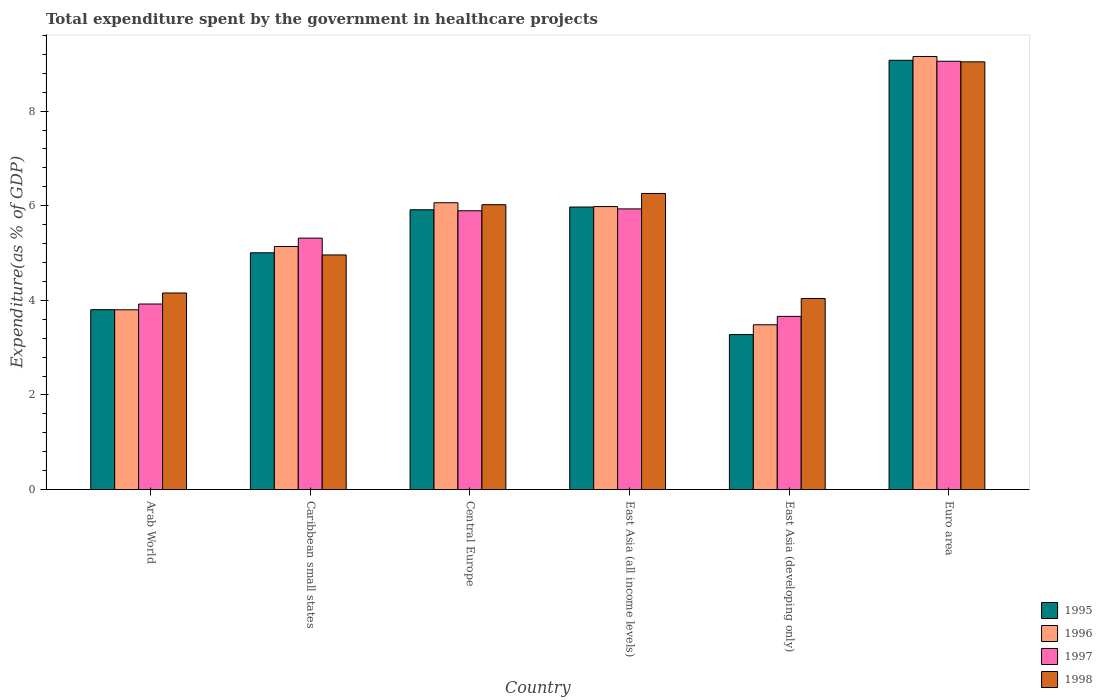Are the number of bars per tick equal to the number of legend labels?
Give a very brief answer. Yes. What is the label of the 1st group of bars from the left?
Offer a very short reply. Arab World. What is the total expenditure spent by the government in healthcare projects in 1995 in East Asia (developing only)?
Ensure brevity in your answer.  3.28. Across all countries, what is the maximum total expenditure spent by the government in healthcare projects in 1996?
Keep it short and to the point. 9.16. Across all countries, what is the minimum total expenditure spent by the government in healthcare projects in 1997?
Your answer should be very brief. 3.66. In which country was the total expenditure spent by the government in healthcare projects in 1996 maximum?
Make the answer very short. Euro area. In which country was the total expenditure spent by the government in healthcare projects in 1997 minimum?
Ensure brevity in your answer.  East Asia (developing only). What is the total total expenditure spent by the government in healthcare projects in 1997 in the graph?
Provide a short and direct response. 33.78. What is the difference between the total expenditure spent by the government in healthcare projects in 1995 in Central Europe and that in East Asia (all income levels)?
Offer a very short reply. -0.06. What is the difference between the total expenditure spent by the government in healthcare projects in 1995 in Euro area and the total expenditure spent by the government in healthcare projects in 1998 in Caribbean small states?
Keep it short and to the point. 4.12. What is the average total expenditure spent by the government in healthcare projects in 1995 per country?
Provide a succinct answer. 5.51. What is the difference between the total expenditure spent by the government in healthcare projects of/in 1995 and total expenditure spent by the government in healthcare projects of/in 1998 in Caribbean small states?
Offer a terse response. 0.05. What is the ratio of the total expenditure spent by the government in healthcare projects in 1997 in Central Europe to that in East Asia (all income levels)?
Offer a very short reply. 0.99. Is the total expenditure spent by the government in healthcare projects in 1998 in Central Europe less than that in East Asia (all income levels)?
Offer a terse response. Yes. What is the difference between the highest and the second highest total expenditure spent by the government in healthcare projects in 1997?
Make the answer very short. 3.16. What is the difference between the highest and the lowest total expenditure spent by the government in healthcare projects in 1998?
Your response must be concise. 5. In how many countries, is the total expenditure spent by the government in healthcare projects in 1997 greater than the average total expenditure spent by the government in healthcare projects in 1997 taken over all countries?
Provide a short and direct response. 3. What does the 3rd bar from the left in Caribbean small states represents?
Your answer should be compact. 1997. What does the 1st bar from the right in East Asia (all income levels) represents?
Offer a terse response. 1998. How many bars are there?
Provide a succinct answer. 24. Are all the bars in the graph horizontal?
Your response must be concise. No. How many countries are there in the graph?
Your response must be concise. 6. Are the values on the major ticks of Y-axis written in scientific E-notation?
Give a very brief answer. No. Does the graph contain any zero values?
Provide a succinct answer. No. Does the graph contain grids?
Your answer should be very brief. No. Where does the legend appear in the graph?
Ensure brevity in your answer.  Bottom right. How many legend labels are there?
Make the answer very short. 4. What is the title of the graph?
Keep it short and to the point. Total expenditure spent by the government in healthcare projects. What is the label or title of the Y-axis?
Make the answer very short. Expenditure(as % of GDP). What is the Expenditure(as % of GDP) in 1995 in Arab World?
Your response must be concise. 3.8. What is the Expenditure(as % of GDP) in 1996 in Arab World?
Your answer should be compact. 3.8. What is the Expenditure(as % of GDP) in 1997 in Arab World?
Make the answer very short. 3.92. What is the Expenditure(as % of GDP) of 1998 in Arab World?
Offer a very short reply. 4.16. What is the Expenditure(as % of GDP) in 1995 in Caribbean small states?
Give a very brief answer. 5.01. What is the Expenditure(as % of GDP) of 1996 in Caribbean small states?
Ensure brevity in your answer.  5.14. What is the Expenditure(as % of GDP) in 1997 in Caribbean small states?
Your response must be concise. 5.32. What is the Expenditure(as % of GDP) of 1998 in Caribbean small states?
Give a very brief answer. 4.96. What is the Expenditure(as % of GDP) in 1995 in Central Europe?
Provide a short and direct response. 5.92. What is the Expenditure(as % of GDP) of 1996 in Central Europe?
Offer a very short reply. 6.06. What is the Expenditure(as % of GDP) of 1997 in Central Europe?
Ensure brevity in your answer.  5.89. What is the Expenditure(as % of GDP) of 1998 in Central Europe?
Your response must be concise. 6.02. What is the Expenditure(as % of GDP) of 1995 in East Asia (all income levels)?
Provide a short and direct response. 5.97. What is the Expenditure(as % of GDP) of 1996 in East Asia (all income levels)?
Ensure brevity in your answer.  5.98. What is the Expenditure(as % of GDP) of 1997 in East Asia (all income levels)?
Your answer should be compact. 5.93. What is the Expenditure(as % of GDP) of 1998 in East Asia (all income levels)?
Provide a succinct answer. 6.26. What is the Expenditure(as % of GDP) of 1995 in East Asia (developing only)?
Offer a terse response. 3.28. What is the Expenditure(as % of GDP) in 1996 in East Asia (developing only)?
Ensure brevity in your answer.  3.48. What is the Expenditure(as % of GDP) in 1997 in East Asia (developing only)?
Make the answer very short. 3.66. What is the Expenditure(as % of GDP) in 1998 in East Asia (developing only)?
Provide a succinct answer. 4.04. What is the Expenditure(as % of GDP) of 1995 in Euro area?
Your answer should be compact. 9.08. What is the Expenditure(as % of GDP) of 1996 in Euro area?
Your answer should be compact. 9.16. What is the Expenditure(as % of GDP) in 1997 in Euro area?
Make the answer very short. 9.06. What is the Expenditure(as % of GDP) in 1998 in Euro area?
Your answer should be very brief. 9.04. Across all countries, what is the maximum Expenditure(as % of GDP) in 1995?
Provide a succinct answer. 9.08. Across all countries, what is the maximum Expenditure(as % of GDP) in 1996?
Provide a short and direct response. 9.16. Across all countries, what is the maximum Expenditure(as % of GDP) of 1997?
Your answer should be very brief. 9.06. Across all countries, what is the maximum Expenditure(as % of GDP) of 1998?
Provide a succinct answer. 9.04. Across all countries, what is the minimum Expenditure(as % of GDP) of 1995?
Offer a very short reply. 3.28. Across all countries, what is the minimum Expenditure(as % of GDP) in 1996?
Provide a short and direct response. 3.48. Across all countries, what is the minimum Expenditure(as % of GDP) in 1997?
Ensure brevity in your answer.  3.66. Across all countries, what is the minimum Expenditure(as % of GDP) in 1998?
Provide a succinct answer. 4.04. What is the total Expenditure(as % of GDP) of 1995 in the graph?
Your answer should be very brief. 33.05. What is the total Expenditure(as % of GDP) in 1996 in the graph?
Keep it short and to the point. 33.62. What is the total Expenditure(as % of GDP) in 1997 in the graph?
Offer a very short reply. 33.78. What is the total Expenditure(as % of GDP) of 1998 in the graph?
Give a very brief answer. 34.48. What is the difference between the Expenditure(as % of GDP) of 1995 in Arab World and that in Caribbean small states?
Make the answer very short. -1.2. What is the difference between the Expenditure(as % of GDP) of 1996 in Arab World and that in Caribbean small states?
Your answer should be very brief. -1.34. What is the difference between the Expenditure(as % of GDP) of 1997 in Arab World and that in Caribbean small states?
Give a very brief answer. -1.39. What is the difference between the Expenditure(as % of GDP) of 1998 in Arab World and that in Caribbean small states?
Provide a succinct answer. -0.8. What is the difference between the Expenditure(as % of GDP) of 1995 in Arab World and that in Central Europe?
Make the answer very short. -2.11. What is the difference between the Expenditure(as % of GDP) in 1996 in Arab World and that in Central Europe?
Offer a terse response. -2.26. What is the difference between the Expenditure(as % of GDP) in 1997 in Arab World and that in Central Europe?
Offer a very short reply. -1.97. What is the difference between the Expenditure(as % of GDP) of 1998 in Arab World and that in Central Europe?
Keep it short and to the point. -1.87. What is the difference between the Expenditure(as % of GDP) of 1995 in Arab World and that in East Asia (all income levels)?
Your answer should be very brief. -2.17. What is the difference between the Expenditure(as % of GDP) in 1996 in Arab World and that in East Asia (all income levels)?
Your answer should be very brief. -2.18. What is the difference between the Expenditure(as % of GDP) in 1997 in Arab World and that in East Asia (all income levels)?
Offer a terse response. -2.01. What is the difference between the Expenditure(as % of GDP) in 1998 in Arab World and that in East Asia (all income levels)?
Ensure brevity in your answer.  -2.1. What is the difference between the Expenditure(as % of GDP) in 1995 in Arab World and that in East Asia (developing only)?
Your answer should be very brief. 0.53. What is the difference between the Expenditure(as % of GDP) in 1996 in Arab World and that in East Asia (developing only)?
Offer a very short reply. 0.32. What is the difference between the Expenditure(as % of GDP) in 1997 in Arab World and that in East Asia (developing only)?
Provide a short and direct response. 0.26. What is the difference between the Expenditure(as % of GDP) in 1998 in Arab World and that in East Asia (developing only)?
Ensure brevity in your answer.  0.12. What is the difference between the Expenditure(as % of GDP) in 1995 in Arab World and that in Euro area?
Give a very brief answer. -5.27. What is the difference between the Expenditure(as % of GDP) in 1996 in Arab World and that in Euro area?
Offer a terse response. -5.36. What is the difference between the Expenditure(as % of GDP) in 1997 in Arab World and that in Euro area?
Your answer should be compact. -5.13. What is the difference between the Expenditure(as % of GDP) in 1998 in Arab World and that in Euro area?
Offer a terse response. -4.89. What is the difference between the Expenditure(as % of GDP) in 1995 in Caribbean small states and that in Central Europe?
Your response must be concise. -0.91. What is the difference between the Expenditure(as % of GDP) in 1996 in Caribbean small states and that in Central Europe?
Your answer should be compact. -0.93. What is the difference between the Expenditure(as % of GDP) of 1997 in Caribbean small states and that in Central Europe?
Give a very brief answer. -0.58. What is the difference between the Expenditure(as % of GDP) of 1998 in Caribbean small states and that in Central Europe?
Offer a terse response. -1.06. What is the difference between the Expenditure(as % of GDP) of 1995 in Caribbean small states and that in East Asia (all income levels)?
Offer a very short reply. -0.97. What is the difference between the Expenditure(as % of GDP) in 1996 in Caribbean small states and that in East Asia (all income levels)?
Keep it short and to the point. -0.84. What is the difference between the Expenditure(as % of GDP) in 1997 in Caribbean small states and that in East Asia (all income levels)?
Offer a very short reply. -0.62. What is the difference between the Expenditure(as % of GDP) of 1998 in Caribbean small states and that in East Asia (all income levels)?
Offer a very short reply. -1.3. What is the difference between the Expenditure(as % of GDP) in 1995 in Caribbean small states and that in East Asia (developing only)?
Your answer should be compact. 1.73. What is the difference between the Expenditure(as % of GDP) in 1996 in Caribbean small states and that in East Asia (developing only)?
Ensure brevity in your answer.  1.65. What is the difference between the Expenditure(as % of GDP) of 1997 in Caribbean small states and that in East Asia (developing only)?
Provide a succinct answer. 1.65. What is the difference between the Expenditure(as % of GDP) in 1998 in Caribbean small states and that in East Asia (developing only)?
Offer a terse response. 0.92. What is the difference between the Expenditure(as % of GDP) of 1995 in Caribbean small states and that in Euro area?
Give a very brief answer. -4.07. What is the difference between the Expenditure(as % of GDP) in 1996 in Caribbean small states and that in Euro area?
Offer a terse response. -4.02. What is the difference between the Expenditure(as % of GDP) in 1997 in Caribbean small states and that in Euro area?
Offer a very short reply. -3.74. What is the difference between the Expenditure(as % of GDP) in 1998 in Caribbean small states and that in Euro area?
Offer a very short reply. -4.08. What is the difference between the Expenditure(as % of GDP) in 1995 in Central Europe and that in East Asia (all income levels)?
Your answer should be very brief. -0.06. What is the difference between the Expenditure(as % of GDP) of 1996 in Central Europe and that in East Asia (all income levels)?
Your answer should be very brief. 0.08. What is the difference between the Expenditure(as % of GDP) in 1997 in Central Europe and that in East Asia (all income levels)?
Give a very brief answer. -0.04. What is the difference between the Expenditure(as % of GDP) of 1998 in Central Europe and that in East Asia (all income levels)?
Your answer should be compact. -0.24. What is the difference between the Expenditure(as % of GDP) of 1995 in Central Europe and that in East Asia (developing only)?
Ensure brevity in your answer.  2.64. What is the difference between the Expenditure(as % of GDP) of 1996 in Central Europe and that in East Asia (developing only)?
Provide a short and direct response. 2.58. What is the difference between the Expenditure(as % of GDP) of 1997 in Central Europe and that in East Asia (developing only)?
Offer a terse response. 2.23. What is the difference between the Expenditure(as % of GDP) of 1998 in Central Europe and that in East Asia (developing only)?
Provide a short and direct response. 1.98. What is the difference between the Expenditure(as % of GDP) of 1995 in Central Europe and that in Euro area?
Give a very brief answer. -3.16. What is the difference between the Expenditure(as % of GDP) in 1996 in Central Europe and that in Euro area?
Give a very brief answer. -3.09. What is the difference between the Expenditure(as % of GDP) in 1997 in Central Europe and that in Euro area?
Make the answer very short. -3.16. What is the difference between the Expenditure(as % of GDP) in 1998 in Central Europe and that in Euro area?
Make the answer very short. -3.02. What is the difference between the Expenditure(as % of GDP) in 1995 in East Asia (all income levels) and that in East Asia (developing only)?
Ensure brevity in your answer.  2.7. What is the difference between the Expenditure(as % of GDP) of 1996 in East Asia (all income levels) and that in East Asia (developing only)?
Offer a terse response. 2.5. What is the difference between the Expenditure(as % of GDP) of 1997 in East Asia (all income levels) and that in East Asia (developing only)?
Keep it short and to the point. 2.27. What is the difference between the Expenditure(as % of GDP) in 1998 in East Asia (all income levels) and that in East Asia (developing only)?
Provide a succinct answer. 2.22. What is the difference between the Expenditure(as % of GDP) of 1995 in East Asia (all income levels) and that in Euro area?
Make the answer very short. -3.1. What is the difference between the Expenditure(as % of GDP) in 1996 in East Asia (all income levels) and that in Euro area?
Provide a short and direct response. -3.17. What is the difference between the Expenditure(as % of GDP) in 1997 in East Asia (all income levels) and that in Euro area?
Give a very brief answer. -3.12. What is the difference between the Expenditure(as % of GDP) of 1998 in East Asia (all income levels) and that in Euro area?
Offer a very short reply. -2.78. What is the difference between the Expenditure(as % of GDP) in 1995 in East Asia (developing only) and that in Euro area?
Give a very brief answer. -5.8. What is the difference between the Expenditure(as % of GDP) in 1996 in East Asia (developing only) and that in Euro area?
Your response must be concise. -5.67. What is the difference between the Expenditure(as % of GDP) of 1997 in East Asia (developing only) and that in Euro area?
Ensure brevity in your answer.  -5.39. What is the difference between the Expenditure(as % of GDP) of 1998 in East Asia (developing only) and that in Euro area?
Your answer should be compact. -5. What is the difference between the Expenditure(as % of GDP) in 1995 in Arab World and the Expenditure(as % of GDP) in 1996 in Caribbean small states?
Offer a terse response. -1.33. What is the difference between the Expenditure(as % of GDP) in 1995 in Arab World and the Expenditure(as % of GDP) in 1997 in Caribbean small states?
Provide a short and direct response. -1.51. What is the difference between the Expenditure(as % of GDP) in 1995 in Arab World and the Expenditure(as % of GDP) in 1998 in Caribbean small states?
Provide a short and direct response. -1.16. What is the difference between the Expenditure(as % of GDP) in 1996 in Arab World and the Expenditure(as % of GDP) in 1997 in Caribbean small states?
Your response must be concise. -1.52. What is the difference between the Expenditure(as % of GDP) of 1996 in Arab World and the Expenditure(as % of GDP) of 1998 in Caribbean small states?
Offer a terse response. -1.16. What is the difference between the Expenditure(as % of GDP) of 1997 in Arab World and the Expenditure(as % of GDP) of 1998 in Caribbean small states?
Provide a short and direct response. -1.04. What is the difference between the Expenditure(as % of GDP) of 1995 in Arab World and the Expenditure(as % of GDP) of 1996 in Central Europe?
Keep it short and to the point. -2.26. What is the difference between the Expenditure(as % of GDP) in 1995 in Arab World and the Expenditure(as % of GDP) in 1997 in Central Europe?
Keep it short and to the point. -2.09. What is the difference between the Expenditure(as % of GDP) in 1995 in Arab World and the Expenditure(as % of GDP) in 1998 in Central Europe?
Provide a succinct answer. -2.22. What is the difference between the Expenditure(as % of GDP) in 1996 in Arab World and the Expenditure(as % of GDP) in 1997 in Central Europe?
Give a very brief answer. -2.09. What is the difference between the Expenditure(as % of GDP) in 1996 in Arab World and the Expenditure(as % of GDP) in 1998 in Central Europe?
Give a very brief answer. -2.22. What is the difference between the Expenditure(as % of GDP) in 1995 in Arab World and the Expenditure(as % of GDP) in 1996 in East Asia (all income levels)?
Keep it short and to the point. -2.18. What is the difference between the Expenditure(as % of GDP) of 1995 in Arab World and the Expenditure(as % of GDP) of 1997 in East Asia (all income levels)?
Provide a succinct answer. -2.13. What is the difference between the Expenditure(as % of GDP) of 1995 in Arab World and the Expenditure(as % of GDP) of 1998 in East Asia (all income levels)?
Make the answer very short. -2.46. What is the difference between the Expenditure(as % of GDP) of 1996 in Arab World and the Expenditure(as % of GDP) of 1997 in East Asia (all income levels)?
Offer a terse response. -2.13. What is the difference between the Expenditure(as % of GDP) in 1996 in Arab World and the Expenditure(as % of GDP) in 1998 in East Asia (all income levels)?
Your answer should be compact. -2.46. What is the difference between the Expenditure(as % of GDP) in 1997 in Arab World and the Expenditure(as % of GDP) in 1998 in East Asia (all income levels)?
Make the answer very short. -2.34. What is the difference between the Expenditure(as % of GDP) in 1995 in Arab World and the Expenditure(as % of GDP) in 1996 in East Asia (developing only)?
Offer a terse response. 0.32. What is the difference between the Expenditure(as % of GDP) of 1995 in Arab World and the Expenditure(as % of GDP) of 1997 in East Asia (developing only)?
Your answer should be compact. 0.14. What is the difference between the Expenditure(as % of GDP) in 1995 in Arab World and the Expenditure(as % of GDP) in 1998 in East Asia (developing only)?
Your answer should be very brief. -0.24. What is the difference between the Expenditure(as % of GDP) in 1996 in Arab World and the Expenditure(as % of GDP) in 1997 in East Asia (developing only)?
Your response must be concise. 0.14. What is the difference between the Expenditure(as % of GDP) of 1996 in Arab World and the Expenditure(as % of GDP) of 1998 in East Asia (developing only)?
Provide a succinct answer. -0.24. What is the difference between the Expenditure(as % of GDP) in 1997 in Arab World and the Expenditure(as % of GDP) in 1998 in East Asia (developing only)?
Your answer should be very brief. -0.12. What is the difference between the Expenditure(as % of GDP) in 1995 in Arab World and the Expenditure(as % of GDP) in 1996 in Euro area?
Give a very brief answer. -5.35. What is the difference between the Expenditure(as % of GDP) of 1995 in Arab World and the Expenditure(as % of GDP) of 1997 in Euro area?
Offer a terse response. -5.25. What is the difference between the Expenditure(as % of GDP) in 1995 in Arab World and the Expenditure(as % of GDP) in 1998 in Euro area?
Make the answer very short. -5.24. What is the difference between the Expenditure(as % of GDP) in 1996 in Arab World and the Expenditure(as % of GDP) in 1997 in Euro area?
Keep it short and to the point. -5.26. What is the difference between the Expenditure(as % of GDP) in 1996 in Arab World and the Expenditure(as % of GDP) in 1998 in Euro area?
Offer a terse response. -5.24. What is the difference between the Expenditure(as % of GDP) of 1997 in Arab World and the Expenditure(as % of GDP) of 1998 in Euro area?
Your answer should be compact. -5.12. What is the difference between the Expenditure(as % of GDP) of 1995 in Caribbean small states and the Expenditure(as % of GDP) of 1996 in Central Europe?
Give a very brief answer. -1.06. What is the difference between the Expenditure(as % of GDP) of 1995 in Caribbean small states and the Expenditure(as % of GDP) of 1997 in Central Europe?
Provide a short and direct response. -0.89. What is the difference between the Expenditure(as % of GDP) in 1995 in Caribbean small states and the Expenditure(as % of GDP) in 1998 in Central Europe?
Ensure brevity in your answer.  -1.02. What is the difference between the Expenditure(as % of GDP) in 1996 in Caribbean small states and the Expenditure(as % of GDP) in 1997 in Central Europe?
Make the answer very short. -0.76. What is the difference between the Expenditure(as % of GDP) of 1996 in Caribbean small states and the Expenditure(as % of GDP) of 1998 in Central Europe?
Provide a short and direct response. -0.88. What is the difference between the Expenditure(as % of GDP) in 1997 in Caribbean small states and the Expenditure(as % of GDP) in 1998 in Central Europe?
Provide a succinct answer. -0.71. What is the difference between the Expenditure(as % of GDP) of 1995 in Caribbean small states and the Expenditure(as % of GDP) of 1996 in East Asia (all income levels)?
Your response must be concise. -0.98. What is the difference between the Expenditure(as % of GDP) in 1995 in Caribbean small states and the Expenditure(as % of GDP) in 1997 in East Asia (all income levels)?
Offer a very short reply. -0.93. What is the difference between the Expenditure(as % of GDP) in 1995 in Caribbean small states and the Expenditure(as % of GDP) in 1998 in East Asia (all income levels)?
Provide a succinct answer. -1.25. What is the difference between the Expenditure(as % of GDP) in 1996 in Caribbean small states and the Expenditure(as % of GDP) in 1997 in East Asia (all income levels)?
Your response must be concise. -0.8. What is the difference between the Expenditure(as % of GDP) in 1996 in Caribbean small states and the Expenditure(as % of GDP) in 1998 in East Asia (all income levels)?
Make the answer very short. -1.12. What is the difference between the Expenditure(as % of GDP) in 1997 in Caribbean small states and the Expenditure(as % of GDP) in 1998 in East Asia (all income levels)?
Ensure brevity in your answer.  -0.94. What is the difference between the Expenditure(as % of GDP) of 1995 in Caribbean small states and the Expenditure(as % of GDP) of 1996 in East Asia (developing only)?
Ensure brevity in your answer.  1.52. What is the difference between the Expenditure(as % of GDP) in 1995 in Caribbean small states and the Expenditure(as % of GDP) in 1997 in East Asia (developing only)?
Your answer should be compact. 1.34. What is the difference between the Expenditure(as % of GDP) in 1995 in Caribbean small states and the Expenditure(as % of GDP) in 1998 in East Asia (developing only)?
Provide a succinct answer. 0.97. What is the difference between the Expenditure(as % of GDP) of 1996 in Caribbean small states and the Expenditure(as % of GDP) of 1997 in East Asia (developing only)?
Your answer should be very brief. 1.48. What is the difference between the Expenditure(as % of GDP) in 1996 in Caribbean small states and the Expenditure(as % of GDP) in 1998 in East Asia (developing only)?
Keep it short and to the point. 1.1. What is the difference between the Expenditure(as % of GDP) in 1997 in Caribbean small states and the Expenditure(as % of GDP) in 1998 in East Asia (developing only)?
Provide a succinct answer. 1.28. What is the difference between the Expenditure(as % of GDP) of 1995 in Caribbean small states and the Expenditure(as % of GDP) of 1996 in Euro area?
Keep it short and to the point. -4.15. What is the difference between the Expenditure(as % of GDP) in 1995 in Caribbean small states and the Expenditure(as % of GDP) in 1997 in Euro area?
Your answer should be compact. -4.05. What is the difference between the Expenditure(as % of GDP) of 1995 in Caribbean small states and the Expenditure(as % of GDP) of 1998 in Euro area?
Ensure brevity in your answer.  -4.04. What is the difference between the Expenditure(as % of GDP) of 1996 in Caribbean small states and the Expenditure(as % of GDP) of 1997 in Euro area?
Provide a succinct answer. -3.92. What is the difference between the Expenditure(as % of GDP) in 1996 in Caribbean small states and the Expenditure(as % of GDP) in 1998 in Euro area?
Provide a succinct answer. -3.9. What is the difference between the Expenditure(as % of GDP) of 1997 in Caribbean small states and the Expenditure(as % of GDP) of 1998 in Euro area?
Your response must be concise. -3.73. What is the difference between the Expenditure(as % of GDP) in 1995 in Central Europe and the Expenditure(as % of GDP) in 1996 in East Asia (all income levels)?
Your response must be concise. -0.07. What is the difference between the Expenditure(as % of GDP) of 1995 in Central Europe and the Expenditure(as % of GDP) of 1997 in East Asia (all income levels)?
Offer a very short reply. -0.02. What is the difference between the Expenditure(as % of GDP) in 1995 in Central Europe and the Expenditure(as % of GDP) in 1998 in East Asia (all income levels)?
Your response must be concise. -0.34. What is the difference between the Expenditure(as % of GDP) in 1996 in Central Europe and the Expenditure(as % of GDP) in 1997 in East Asia (all income levels)?
Your answer should be very brief. 0.13. What is the difference between the Expenditure(as % of GDP) in 1996 in Central Europe and the Expenditure(as % of GDP) in 1998 in East Asia (all income levels)?
Offer a terse response. -0.2. What is the difference between the Expenditure(as % of GDP) in 1997 in Central Europe and the Expenditure(as % of GDP) in 1998 in East Asia (all income levels)?
Offer a terse response. -0.37. What is the difference between the Expenditure(as % of GDP) in 1995 in Central Europe and the Expenditure(as % of GDP) in 1996 in East Asia (developing only)?
Provide a succinct answer. 2.43. What is the difference between the Expenditure(as % of GDP) of 1995 in Central Europe and the Expenditure(as % of GDP) of 1997 in East Asia (developing only)?
Provide a succinct answer. 2.25. What is the difference between the Expenditure(as % of GDP) of 1995 in Central Europe and the Expenditure(as % of GDP) of 1998 in East Asia (developing only)?
Offer a terse response. 1.88. What is the difference between the Expenditure(as % of GDP) of 1996 in Central Europe and the Expenditure(as % of GDP) of 1997 in East Asia (developing only)?
Your response must be concise. 2.4. What is the difference between the Expenditure(as % of GDP) of 1996 in Central Europe and the Expenditure(as % of GDP) of 1998 in East Asia (developing only)?
Your answer should be very brief. 2.02. What is the difference between the Expenditure(as % of GDP) in 1997 in Central Europe and the Expenditure(as % of GDP) in 1998 in East Asia (developing only)?
Ensure brevity in your answer.  1.86. What is the difference between the Expenditure(as % of GDP) in 1995 in Central Europe and the Expenditure(as % of GDP) in 1996 in Euro area?
Ensure brevity in your answer.  -3.24. What is the difference between the Expenditure(as % of GDP) in 1995 in Central Europe and the Expenditure(as % of GDP) in 1997 in Euro area?
Offer a terse response. -3.14. What is the difference between the Expenditure(as % of GDP) in 1995 in Central Europe and the Expenditure(as % of GDP) in 1998 in Euro area?
Make the answer very short. -3.13. What is the difference between the Expenditure(as % of GDP) in 1996 in Central Europe and the Expenditure(as % of GDP) in 1997 in Euro area?
Provide a succinct answer. -2.99. What is the difference between the Expenditure(as % of GDP) in 1996 in Central Europe and the Expenditure(as % of GDP) in 1998 in Euro area?
Give a very brief answer. -2.98. What is the difference between the Expenditure(as % of GDP) of 1997 in Central Europe and the Expenditure(as % of GDP) of 1998 in Euro area?
Ensure brevity in your answer.  -3.15. What is the difference between the Expenditure(as % of GDP) in 1995 in East Asia (all income levels) and the Expenditure(as % of GDP) in 1996 in East Asia (developing only)?
Offer a very short reply. 2.49. What is the difference between the Expenditure(as % of GDP) in 1995 in East Asia (all income levels) and the Expenditure(as % of GDP) in 1997 in East Asia (developing only)?
Offer a terse response. 2.31. What is the difference between the Expenditure(as % of GDP) of 1995 in East Asia (all income levels) and the Expenditure(as % of GDP) of 1998 in East Asia (developing only)?
Your response must be concise. 1.93. What is the difference between the Expenditure(as % of GDP) in 1996 in East Asia (all income levels) and the Expenditure(as % of GDP) in 1997 in East Asia (developing only)?
Your answer should be very brief. 2.32. What is the difference between the Expenditure(as % of GDP) in 1996 in East Asia (all income levels) and the Expenditure(as % of GDP) in 1998 in East Asia (developing only)?
Your answer should be compact. 1.94. What is the difference between the Expenditure(as % of GDP) in 1997 in East Asia (all income levels) and the Expenditure(as % of GDP) in 1998 in East Asia (developing only)?
Your answer should be compact. 1.89. What is the difference between the Expenditure(as % of GDP) of 1995 in East Asia (all income levels) and the Expenditure(as % of GDP) of 1996 in Euro area?
Your answer should be compact. -3.18. What is the difference between the Expenditure(as % of GDP) of 1995 in East Asia (all income levels) and the Expenditure(as % of GDP) of 1997 in Euro area?
Your answer should be very brief. -3.08. What is the difference between the Expenditure(as % of GDP) of 1995 in East Asia (all income levels) and the Expenditure(as % of GDP) of 1998 in Euro area?
Offer a very short reply. -3.07. What is the difference between the Expenditure(as % of GDP) in 1996 in East Asia (all income levels) and the Expenditure(as % of GDP) in 1997 in Euro area?
Make the answer very short. -3.07. What is the difference between the Expenditure(as % of GDP) in 1996 in East Asia (all income levels) and the Expenditure(as % of GDP) in 1998 in Euro area?
Provide a short and direct response. -3.06. What is the difference between the Expenditure(as % of GDP) in 1997 in East Asia (all income levels) and the Expenditure(as % of GDP) in 1998 in Euro area?
Keep it short and to the point. -3.11. What is the difference between the Expenditure(as % of GDP) in 1995 in East Asia (developing only) and the Expenditure(as % of GDP) in 1996 in Euro area?
Offer a terse response. -5.88. What is the difference between the Expenditure(as % of GDP) of 1995 in East Asia (developing only) and the Expenditure(as % of GDP) of 1997 in Euro area?
Your response must be concise. -5.78. What is the difference between the Expenditure(as % of GDP) in 1995 in East Asia (developing only) and the Expenditure(as % of GDP) in 1998 in Euro area?
Your response must be concise. -5.77. What is the difference between the Expenditure(as % of GDP) in 1996 in East Asia (developing only) and the Expenditure(as % of GDP) in 1997 in Euro area?
Your answer should be compact. -5.57. What is the difference between the Expenditure(as % of GDP) in 1996 in East Asia (developing only) and the Expenditure(as % of GDP) in 1998 in Euro area?
Provide a short and direct response. -5.56. What is the difference between the Expenditure(as % of GDP) of 1997 in East Asia (developing only) and the Expenditure(as % of GDP) of 1998 in Euro area?
Ensure brevity in your answer.  -5.38. What is the average Expenditure(as % of GDP) of 1995 per country?
Your answer should be very brief. 5.51. What is the average Expenditure(as % of GDP) of 1996 per country?
Offer a very short reply. 5.6. What is the average Expenditure(as % of GDP) in 1997 per country?
Provide a short and direct response. 5.63. What is the average Expenditure(as % of GDP) in 1998 per country?
Give a very brief answer. 5.75. What is the difference between the Expenditure(as % of GDP) in 1995 and Expenditure(as % of GDP) in 1996 in Arab World?
Provide a short and direct response. 0. What is the difference between the Expenditure(as % of GDP) in 1995 and Expenditure(as % of GDP) in 1997 in Arab World?
Your answer should be compact. -0.12. What is the difference between the Expenditure(as % of GDP) of 1995 and Expenditure(as % of GDP) of 1998 in Arab World?
Offer a very short reply. -0.35. What is the difference between the Expenditure(as % of GDP) of 1996 and Expenditure(as % of GDP) of 1997 in Arab World?
Give a very brief answer. -0.12. What is the difference between the Expenditure(as % of GDP) in 1996 and Expenditure(as % of GDP) in 1998 in Arab World?
Offer a very short reply. -0.36. What is the difference between the Expenditure(as % of GDP) of 1997 and Expenditure(as % of GDP) of 1998 in Arab World?
Keep it short and to the point. -0.23. What is the difference between the Expenditure(as % of GDP) in 1995 and Expenditure(as % of GDP) in 1996 in Caribbean small states?
Ensure brevity in your answer.  -0.13. What is the difference between the Expenditure(as % of GDP) of 1995 and Expenditure(as % of GDP) of 1997 in Caribbean small states?
Give a very brief answer. -0.31. What is the difference between the Expenditure(as % of GDP) in 1995 and Expenditure(as % of GDP) in 1998 in Caribbean small states?
Keep it short and to the point. 0.05. What is the difference between the Expenditure(as % of GDP) in 1996 and Expenditure(as % of GDP) in 1997 in Caribbean small states?
Offer a very short reply. -0.18. What is the difference between the Expenditure(as % of GDP) of 1996 and Expenditure(as % of GDP) of 1998 in Caribbean small states?
Offer a very short reply. 0.18. What is the difference between the Expenditure(as % of GDP) of 1997 and Expenditure(as % of GDP) of 1998 in Caribbean small states?
Your answer should be very brief. 0.36. What is the difference between the Expenditure(as % of GDP) in 1995 and Expenditure(as % of GDP) in 1996 in Central Europe?
Offer a terse response. -0.15. What is the difference between the Expenditure(as % of GDP) of 1995 and Expenditure(as % of GDP) of 1997 in Central Europe?
Keep it short and to the point. 0.02. What is the difference between the Expenditure(as % of GDP) of 1995 and Expenditure(as % of GDP) of 1998 in Central Europe?
Provide a succinct answer. -0.11. What is the difference between the Expenditure(as % of GDP) in 1996 and Expenditure(as % of GDP) in 1997 in Central Europe?
Your answer should be very brief. 0.17. What is the difference between the Expenditure(as % of GDP) in 1996 and Expenditure(as % of GDP) in 1998 in Central Europe?
Offer a terse response. 0.04. What is the difference between the Expenditure(as % of GDP) of 1997 and Expenditure(as % of GDP) of 1998 in Central Europe?
Your answer should be very brief. -0.13. What is the difference between the Expenditure(as % of GDP) of 1995 and Expenditure(as % of GDP) of 1996 in East Asia (all income levels)?
Provide a short and direct response. -0.01. What is the difference between the Expenditure(as % of GDP) of 1995 and Expenditure(as % of GDP) of 1997 in East Asia (all income levels)?
Provide a succinct answer. 0.04. What is the difference between the Expenditure(as % of GDP) of 1995 and Expenditure(as % of GDP) of 1998 in East Asia (all income levels)?
Provide a short and direct response. -0.29. What is the difference between the Expenditure(as % of GDP) of 1996 and Expenditure(as % of GDP) of 1997 in East Asia (all income levels)?
Provide a succinct answer. 0.05. What is the difference between the Expenditure(as % of GDP) in 1996 and Expenditure(as % of GDP) in 1998 in East Asia (all income levels)?
Make the answer very short. -0.28. What is the difference between the Expenditure(as % of GDP) of 1997 and Expenditure(as % of GDP) of 1998 in East Asia (all income levels)?
Your answer should be very brief. -0.33. What is the difference between the Expenditure(as % of GDP) in 1995 and Expenditure(as % of GDP) in 1996 in East Asia (developing only)?
Provide a short and direct response. -0.21. What is the difference between the Expenditure(as % of GDP) in 1995 and Expenditure(as % of GDP) in 1997 in East Asia (developing only)?
Make the answer very short. -0.38. What is the difference between the Expenditure(as % of GDP) of 1995 and Expenditure(as % of GDP) of 1998 in East Asia (developing only)?
Give a very brief answer. -0.76. What is the difference between the Expenditure(as % of GDP) of 1996 and Expenditure(as % of GDP) of 1997 in East Asia (developing only)?
Offer a terse response. -0.18. What is the difference between the Expenditure(as % of GDP) in 1996 and Expenditure(as % of GDP) in 1998 in East Asia (developing only)?
Your answer should be very brief. -0.56. What is the difference between the Expenditure(as % of GDP) in 1997 and Expenditure(as % of GDP) in 1998 in East Asia (developing only)?
Ensure brevity in your answer.  -0.38. What is the difference between the Expenditure(as % of GDP) in 1995 and Expenditure(as % of GDP) in 1996 in Euro area?
Keep it short and to the point. -0.08. What is the difference between the Expenditure(as % of GDP) of 1995 and Expenditure(as % of GDP) of 1997 in Euro area?
Ensure brevity in your answer.  0.02. What is the difference between the Expenditure(as % of GDP) in 1995 and Expenditure(as % of GDP) in 1998 in Euro area?
Give a very brief answer. 0.03. What is the difference between the Expenditure(as % of GDP) in 1996 and Expenditure(as % of GDP) in 1997 in Euro area?
Ensure brevity in your answer.  0.1. What is the difference between the Expenditure(as % of GDP) of 1996 and Expenditure(as % of GDP) of 1998 in Euro area?
Ensure brevity in your answer.  0.11. What is the difference between the Expenditure(as % of GDP) of 1997 and Expenditure(as % of GDP) of 1998 in Euro area?
Provide a succinct answer. 0.01. What is the ratio of the Expenditure(as % of GDP) in 1995 in Arab World to that in Caribbean small states?
Your response must be concise. 0.76. What is the ratio of the Expenditure(as % of GDP) of 1996 in Arab World to that in Caribbean small states?
Give a very brief answer. 0.74. What is the ratio of the Expenditure(as % of GDP) of 1997 in Arab World to that in Caribbean small states?
Provide a succinct answer. 0.74. What is the ratio of the Expenditure(as % of GDP) in 1998 in Arab World to that in Caribbean small states?
Ensure brevity in your answer.  0.84. What is the ratio of the Expenditure(as % of GDP) in 1995 in Arab World to that in Central Europe?
Offer a very short reply. 0.64. What is the ratio of the Expenditure(as % of GDP) of 1996 in Arab World to that in Central Europe?
Offer a terse response. 0.63. What is the ratio of the Expenditure(as % of GDP) in 1997 in Arab World to that in Central Europe?
Keep it short and to the point. 0.67. What is the ratio of the Expenditure(as % of GDP) of 1998 in Arab World to that in Central Europe?
Make the answer very short. 0.69. What is the ratio of the Expenditure(as % of GDP) in 1995 in Arab World to that in East Asia (all income levels)?
Keep it short and to the point. 0.64. What is the ratio of the Expenditure(as % of GDP) of 1996 in Arab World to that in East Asia (all income levels)?
Provide a short and direct response. 0.64. What is the ratio of the Expenditure(as % of GDP) of 1997 in Arab World to that in East Asia (all income levels)?
Your response must be concise. 0.66. What is the ratio of the Expenditure(as % of GDP) of 1998 in Arab World to that in East Asia (all income levels)?
Provide a succinct answer. 0.66. What is the ratio of the Expenditure(as % of GDP) of 1995 in Arab World to that in East Asia (developing only)?
Keep it short and to the point. 1.16. What is the ratio of the Expenditure(as % of GDP) of 1996 in Arab World to that in East Asia (developing only)?
Keep it short and to the point. 1.09. What is the ratio of the Expenditure(as % of GDP) in 1997 in Arab World to that in East Asia (developing only)?
Ensure brevity in your answer.  1.07. What is the ratio of the Expenditure(as % of GDP) in 1998 in Arab World to that in East Asia (developing only)?
Keep it short and to the point. 1.03. What is the ratio of the Expenditure(as % of GDP) of 1995 in Arab World to that in Euro area?
Provide a short and direct response. 0.42. What is the ratio of the Expenditure(as % of GDP) in 1996 in Arab World to that in Euro area?
Make the answer very short. 0.42. What is the ratio of the Expenditure(as % of GDP) in 1997 in Arab World to that in Euro area?
Provide a succinct answer. 0.43. What is the ratio of the Expenditure(as % of GDP) in 1998 in Arab World to that in Euro area?
Offer a very short reply. 0.46. What is the ratio of the Expenditure(as % of GDP) of 1995 in Caribbean small states to that in Central Europe?
Provide a succinct answer. 0.85. What is the ratio of the Expenditure(as % of GDP) of 1996 in Caribbean small states to that in Central Europe?
Offer a very short reply. 0.85. What is the ratio of the Expenditure(as % of GDP) in 1997 in Caribbean small states to that in Central Europe?
Your answer should be very brief. 0.9. What is the ratio of the Expenditure(as % of GDP) of 1998 in Caribbean small states to that in Central Europe?
Provide a succinct answer. 0.82. What is the ratio of the Expenditure(as % of GDP) in 1995 in Caribbean small states to that in East Asia (all income levels)?
Your answer should be compact. 0.84. What is the ratio of the Expenditure(as % of GDP) in 1996 in Caribbean small states to that in East Asia (all income levels)?
Give a very brief answer. 0.86. What is the ratio of the Expenditure(as % of GDP) of 1997 in Caribbean small states to that in East Asia (all income levels)?
Provide a succinct answer. 0.9. What is the ratio of the Expenditure(as % of GDP) of 1998 in Caribbean small states to that in East Asia (all income levels)?
Offer a very short reply. 0.79. What is the ratio of the Expenditure(as % of GDP) in 1995 in Caribbean small states to that in East Asia (developing only)?
Provide a short and direct response. 1.53. What is the ratio of the Expenditure(as % of GDP) in 1996 in Caribbean small states to that in East Asia (developing only)?
Ensure brevity in your answer.  1.48. What is the ratio of the Expenditure(as % of GDP) of 1997 in Caribbean small states to that in East Asia (developing only)?
Offer a terse response. 1.45. What is the ratio of the Expenditure(as % of GDP) in 1998 in Caribbean small states to that in East Asia (developing only)?
Make the answer very short. 1.23. What is the ratio of the Expenditure(as % of GDP) in 1995 in Caribbean small states to that in Euro area?
Offer a terse response. 0.55. What is the ratio of the Expenditure(as % of GDP) of 1996 in Caribbean small states to that in Euro area?
Ensure brevity in your answer.  0.56. What is the ratio of the Expenditure(as % of GDP) of 1997 in Caribbean small states to that in Euro area?
Your response must be concise. 0.59. What is the ratio of the Expenditure(as % of GDP) of 1998 in Caribbean small states to that in Euro area?
Ensure brevity in your answer.  0.55. What is the ratio of the Expenditure(as % of GDP) in 1995 in Central Europe to that in East Asia (all income levels)?
Your answer should be compact. 0.99. What is the ratio of the Expenditure(as % of GDP) of 1996 in Central Europe to that in East Asia (all income levels)?
Keep it short and to the point. 1.01. What is the ratio of the Expenditure(as % of GDP) in 1997 in Central Europe to that in East Asia (all income levels)?
Your answer should be compact. 0.99. What is the ratio of the Expenditure(as % of GDP) of 1998 in Central Europe to that in East Asia (all income levels)?
Your answer should be very brief. 0.96. What is the ratio of the Expenditure(as % of GDP) in 1995 in Central Europe to that in East Asia (developing only)?
Provide a succinct answer. 1.81. What is the ratio of the Expenditure(as % of GDP) of 1996 in Central Europe to that in East Asia (developing only)?
Your answer should be very brief. 1.74. What is the ratio of the Expenditure(as % of GDP) in 1997 in Central Europe to that in East Asia (developing only)?
Give a very brief answer. 1.61. What is the ratio of the Expenditure(as % of GDP) in 1998 in Central Europe to that in East Asia (developing only)?
Your response must be concise. 1.49. What is the ratio of the Expenditure(as % of GDP) of 1995 in Central Europe to that in Euro area?
Give a very brief answer. 0.65. What is the ratio of the Expenditure(as % of GDP) in 1996 in Central Europe to that in Euro area?
Offer a terse response. 0.66. What is the ratio of the Expenditure(as % of GDP) in 1997 in Central Europe to that in Euro area?
Provide a succinct answer. 0.65. What is the ratio of the Expenditure(as % of GDP) in 1998 in Central Europe to that in Euro area?
Ensure brevity in your answer.  0.67. What is the ratio of the Expenditure(as % of GDP) of 1995 in East Asia (all income levels) to that in East Asia (developing only)?
Ensure brevity in your answer.  1.82. What is the ratio of the Expenditure(as % of GDP) in 1996 in East Asia (all income levels) to that in East Asia (developing only)?
Give a very brief answer. 1.72. What is the ratio of the Expenditure(as % of GDP) in 1997 in East Asia (all income levels) to that in East Asia (developing only)?
Provide a succinct answer. 1.62. What is the ratio of the Expenditure(as % of GDP) in 1998 in East Asia (all income levels) to that in East Asia (developing only)?
Offer a terse response. 1.55. What is the ratio of the Expenditure(as % of GDP) in 1995 in East Asia (all income levels) to that in Euro area?
Give a very brief answer. 0.66. What is the ratio of the Expenditure(as % of GDP) in 1996 in East Asia (all income levels) to that in Euro area?
Keep it short and to the point. 0.65. What is the ratio of the Expenditure(as % of GDP) of 1997 in East Asia (all income levels) to that in Euro area?
Offer a very short reply. 0.66. What is the ratio of the Expenditure(as % of GDP) of 1998 in East Asia (all income levels) to that in Euro area?
Offer a terse response. 0.69. What is the ratio of the Expenditure(as % of GDP) of 1995 in East Asia (developing only) to that in Euro area?
Provide a succinct answer. 0.36. What is the ratio of the Expenditure(as % of GDP) of 1996 in East Asia (developing only) to that in Euro area?
Make the answer very short. 0.38. What is the ratio of the Expenditure(as % of GDP) of 1997 in East Asia (developing only) to that in Euro area?
Your answer should be compact. 0.4. What is the ratio of the Expenditure(as % of GDP) in 1998 in East Asia (developing only) to that in Euro area?
Keep it short and to the point. 0.45. What is the difference between the highest and the second highest Expenditure(as % of GDP) of 1995?
Offer a terse response. 3.1. What is the difference between the highest and the second highest Expenditure(as % of GDP) of 1996?
Offer a terse response. 3.09. What is the difference between the highest and the second highest Expenditure(as % of GDP) of 1997?
Ensure brevity in your answer.  3.12. What is the difference between the highest and the second highest Expenditure(as % of GDP) of 1998?
Keep it short and to the point. 2.78. What is the difference between the highest and the lowest Expenditure(as % of GDP) of 1995?
Ensure brevity in your answer.  5.8. What is the difference between the highest and the lowest Expenditure(as % of GDP) of 1996?
Offer a terse response. 5.67. What is the difference between the highest and the lowest Expenditure(as % of GDP) of 1997?
Ensure brevity in your answer.  5.39. What is the difference between the highest and the lowest Expenditure(as % of GDP) of 1998?
Give a very brief answer. 5. 